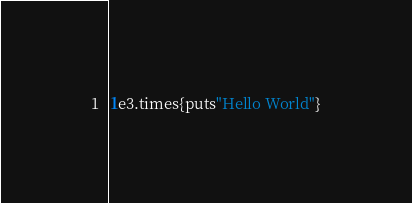<code> <loc_0><loc_0><loc_500><loc_500><_Ruby_>1e3.times{puts"Hello World"}</code> 